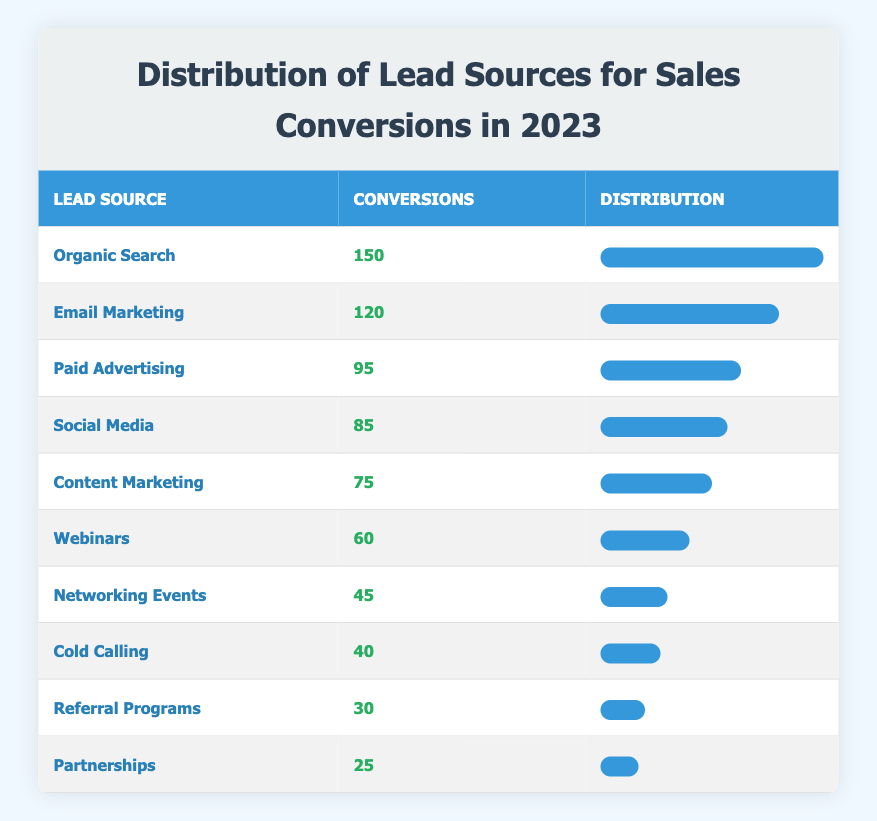What is the highest number of conversions from a single lead source? The table shows that "Organic Search" has the highest number of conversions, which is 150.
Answer: 150 Which lead source has the lowest conversions? Looking through the table, "Partnerships" has the lowest number of conversions with a count of 25.
Answer: 25 What is the total number of conversions from all lead sources? To find the total, we sum all the conversions: (150 + 120 + 95 + 85 + 75 + 60 + 45 + 40 + 30 + 25) = 750. Thus, the total is 750.
Answer: 750 Is the number of conversions from "Paid Advertising" greater than both "Social Media" and "Content Marketing"? "Paid Advertising" has 95 conversions, "Social Media" has 85, and "Content Marketing" has 75. Since 95 is greater than both 85 and 75, the statement is true.
Answer: Yes What is the difference in conversions between "Email Marketing" and "Networking Events"? "Email Marketing" has 120 conversions, while "Networking Events" has 45. The difference is calculated as 120 - 45 = 75.
Answer: 75 Which two lead sources combined have more conversions than "Organic Search"? "Email Marketing" (120) and "Paid Advertising" (95) combined have 120 + 95 = 215 conversions. This total (215) is greater than "Organic Search" (150). Thus, these two sources combined surpass "Organic Search."
Answer: Yes Which lead source accounts for more than 10 percent of total conversions? First, we found the total conversions to be 750. Then, any source with conversions greater than 75 (10% of 750) qualifies. The qualifying sources are "Organic Search," "Email Marketing," "Paid Advertising," and "Social Media."
Answer: Yes What percentage of total conversions does "Referral Programs" represent? "Referral Programs" has 30 conversions. To find the percentage, we calculate (30 / 750) * 100 = 4%. Therefore, "Referral Programs" represent 4% of the total conversions.
Answer: 4% 